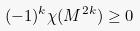<formula> <loc_0><loc_0><loc_500><loc_500>( - 1 ) ^ { k } \chi ( M ^ { 2 k } ) \geq 0</formula> 